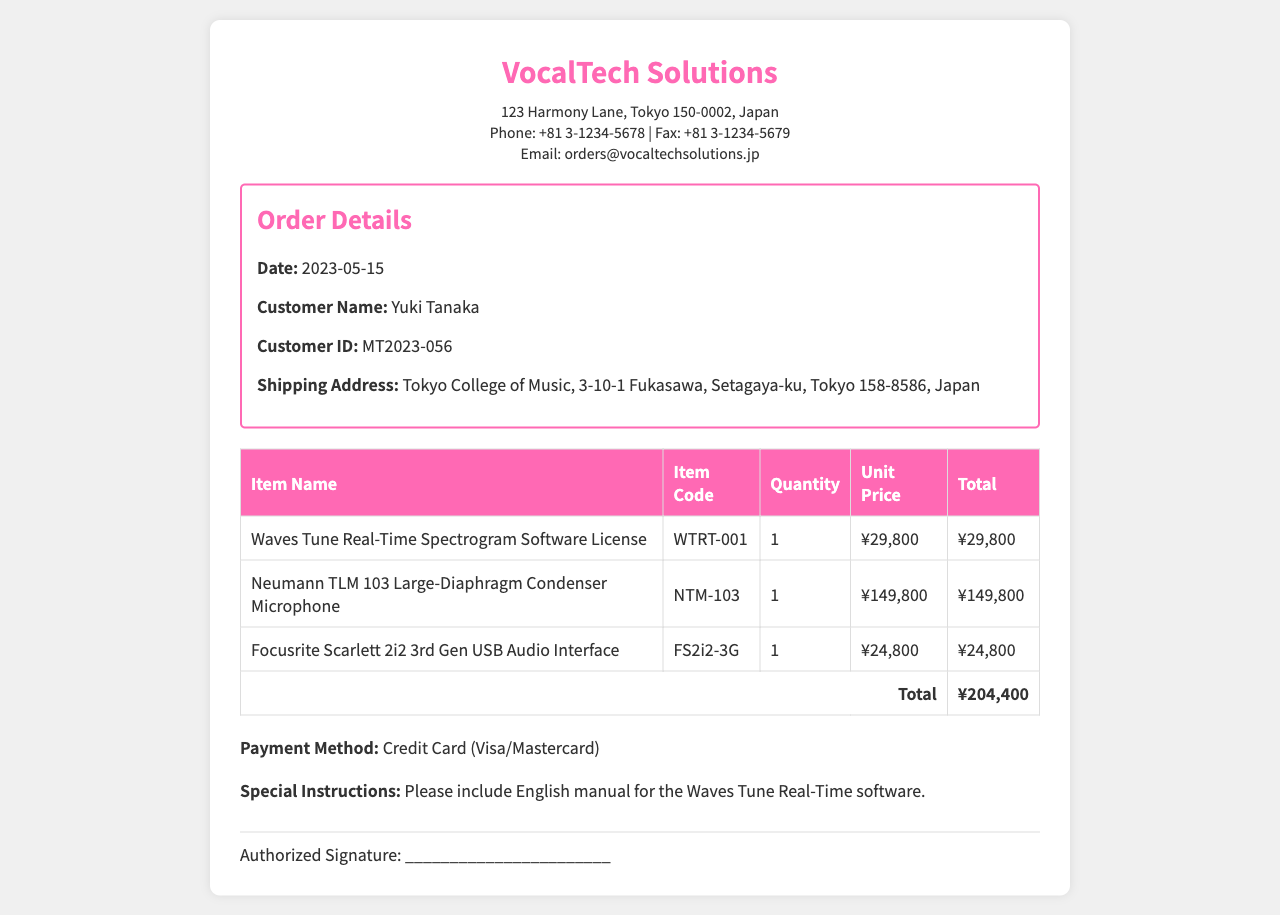What is the order date? The order date is mentioned in the order details section of the document.
Answer: 2023-05-15 Who is the customer? The customer's name is specified in the order details section.
Answer: Yuki Tanaka What is the shipping address? The shipping address for the order is provided in the order details.
Answer: Tokyo College of Music, 3-10-1 Fukasawa, Setagaya-ku, Tokyo 158-8586, Japan What is the total amount? The total amount is calculated based on the sum of all item totals in the order details.
Answer: ¥204,400 What is the item code for the microphone? The item code for the Neumann TLM 103 Large-Diaphragm Condenser Microphone is listed in the item table.
Answer: NTM-103 What type of payment method is used? The payment method is mentioned at the end of the order details.
Answer: Credit Card (Visa/Mastercard) What special instruction was provided? The special instructions included in the order details request a specific item.
Answer: Please include English manual for the Waves Tune Real-Time software 